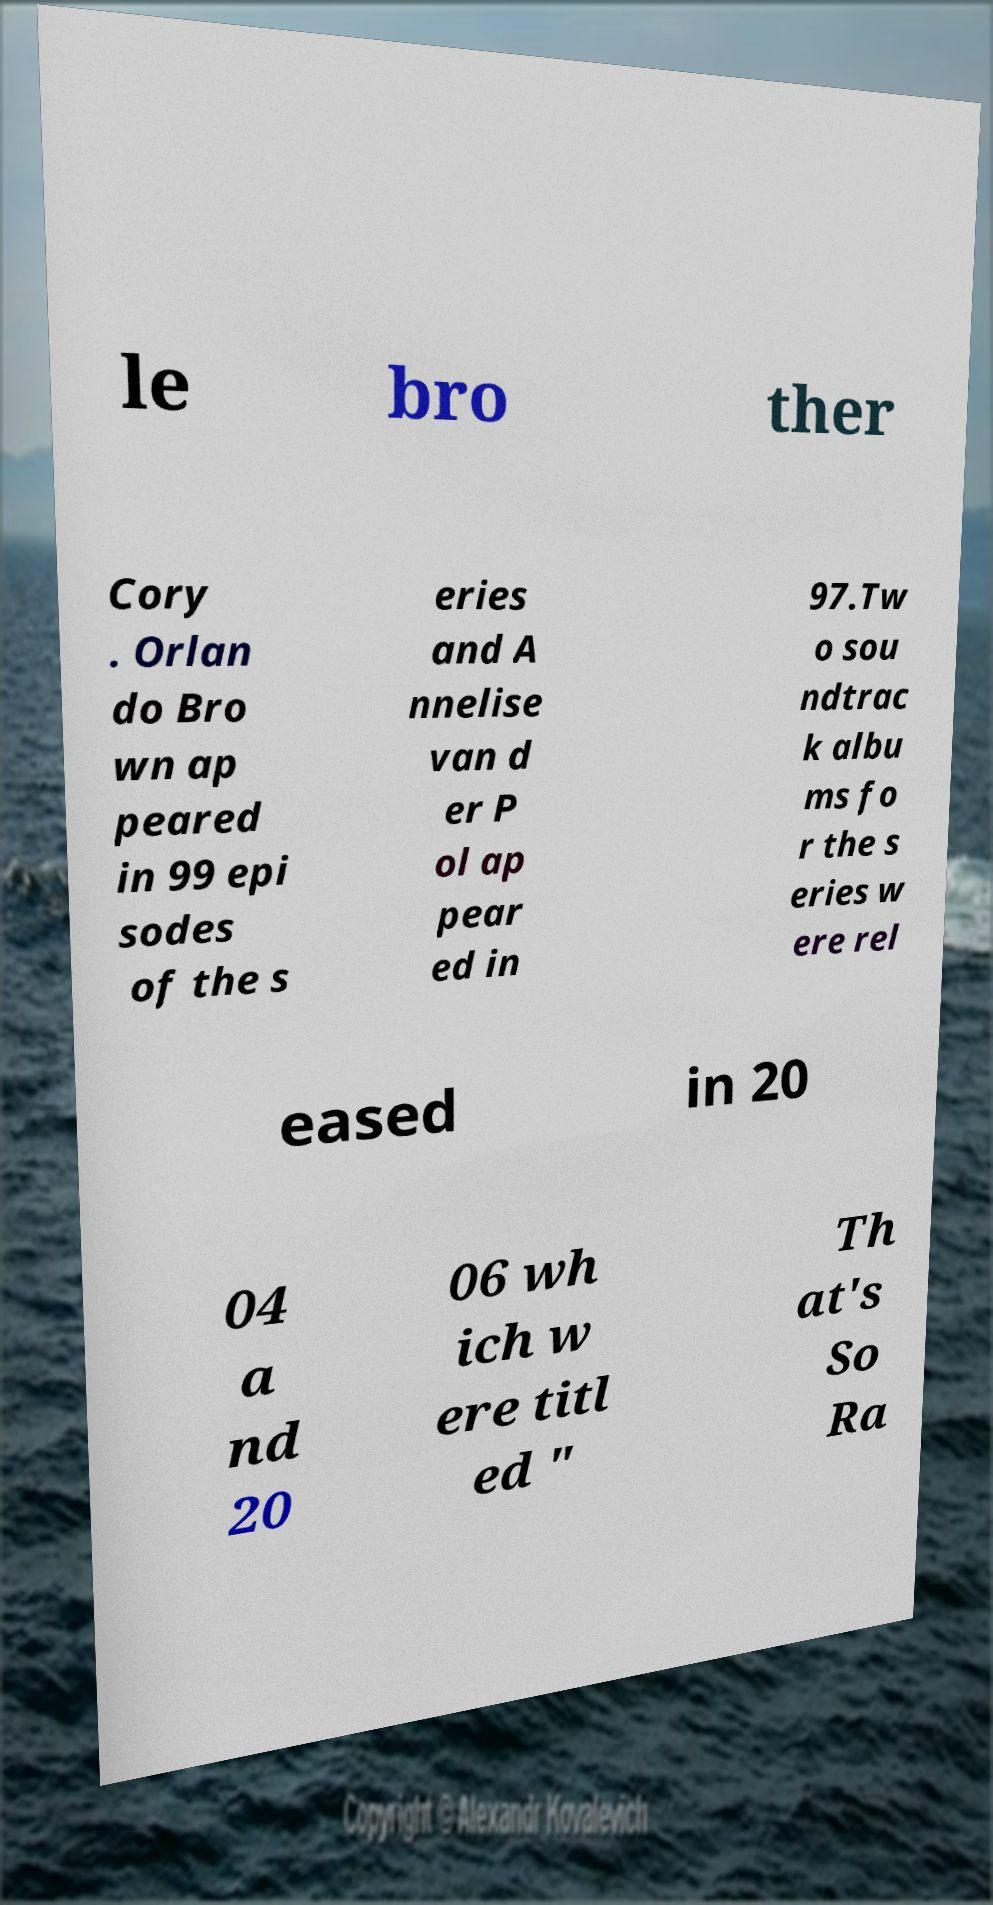Can you read and provide the text displayed in the image?This photo seems to have some interesting text. Can you extract and type it out for me? le bro ther Cory . Orlan do Bro wn ap peared in 99 epi sodes of the s eries and A nnelise van d er P ol ap pear ed in 97.Tw o sou ndtrac k albu ms fo r the s eries w ere rel eased in 20 04 a nd 20 06 wh ich w ere titl ed " Th at's So Ra 